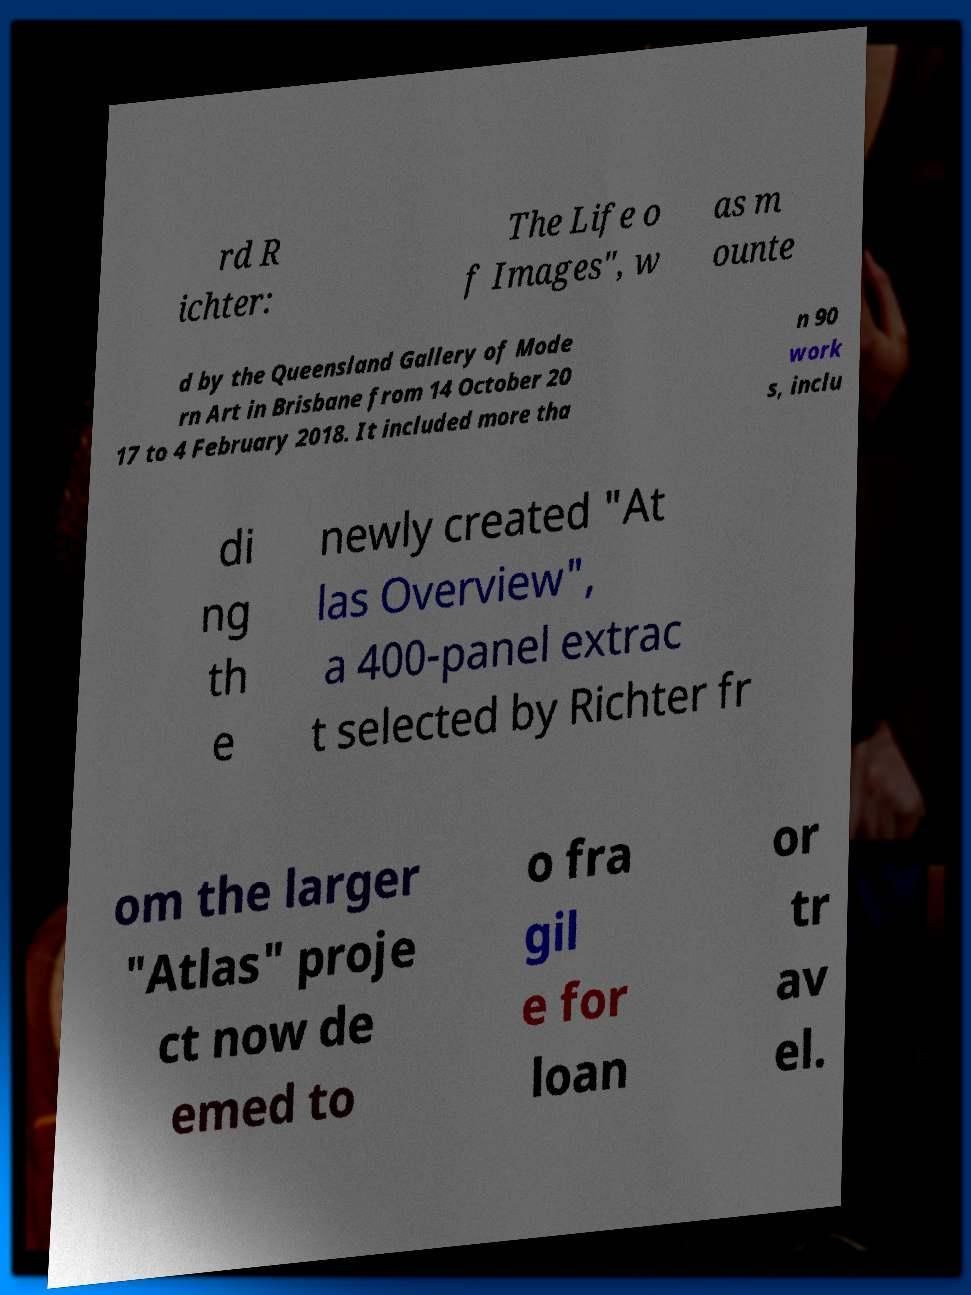Please read and relay the text visible in this image. What does it say? rd R ichter: The Life o f Images", w as m ounte d by the Queensland Gallery of Mode rn Art in Brisbane from 14 October 20 17 to 4 February 2018. It included more tha n 90 work s, inclu di ng th e newly created "At las Overview", a 400-panel extrac t selected by Richter fr om the larger "Atlas" proje ct now de emed to o fra gil e for loan or tr av el. 